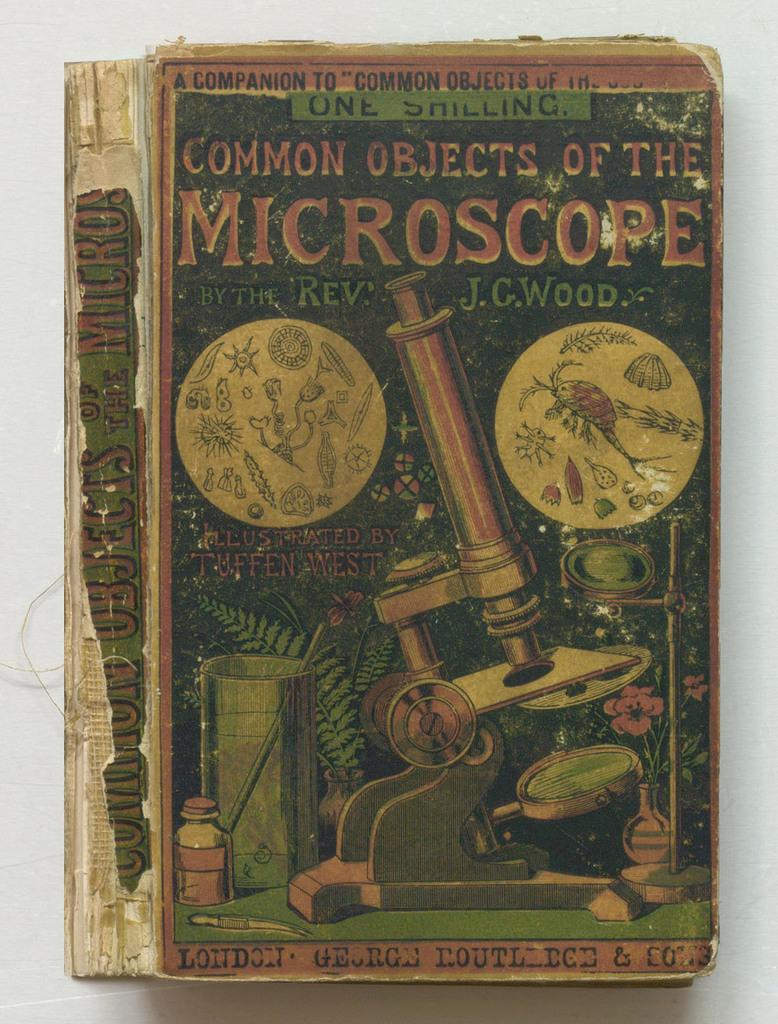What does the binding say on this book?
Your response must be concise. Common objects of the microscope. What this written in london?
Give a very brief answer. Yes. 